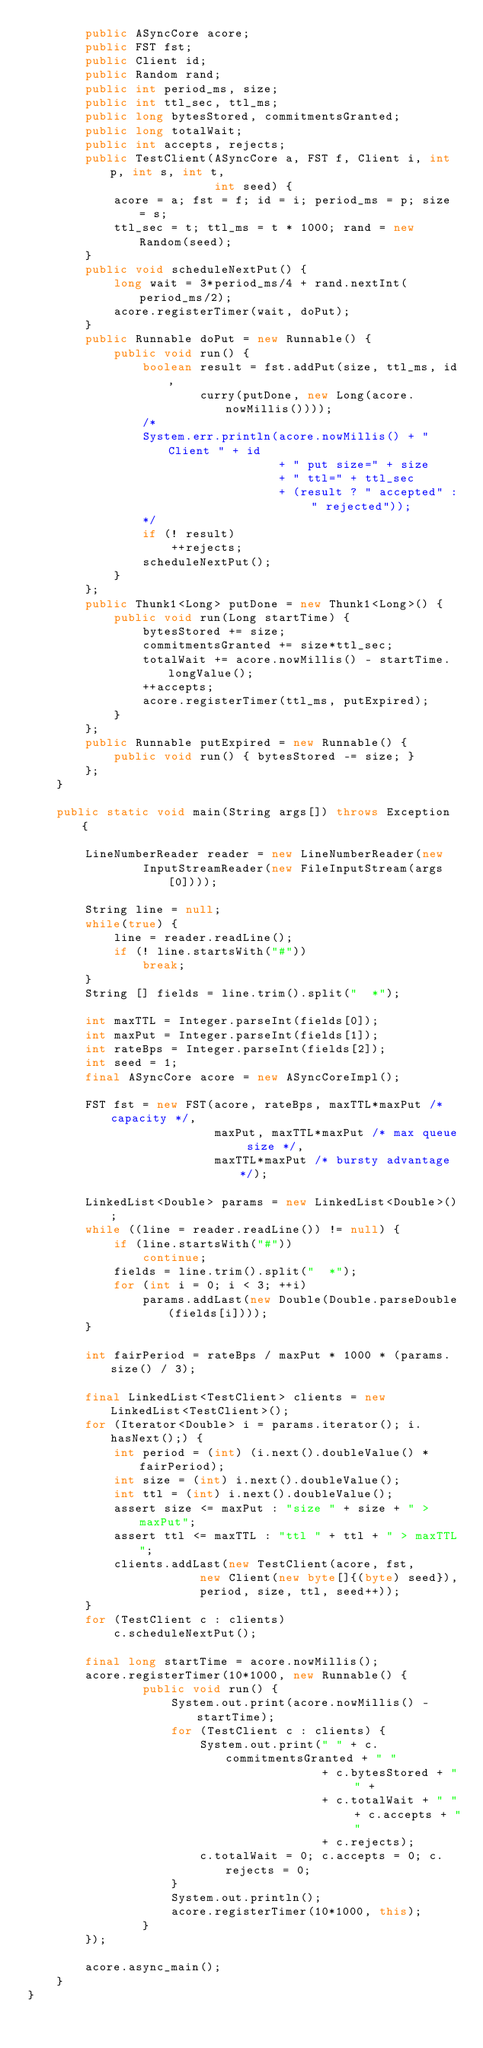<code> <loc_0><loc_0><loc_500><loc_500><_Java_>        public ASyncCore acore;
        public FST fst;
        public Client id;
        public Random rand;
        public int period_ms, size;
        public int ttl_sec, ttl_ms;
        public long bytesStored, commitmentsGranted;
        public long totalWait;
        public int accepts, rejects;
        public TestClient(ASyncCore a, FST f, Client i, int p, int s, int t,
                          int seed) {
            acore = a; fst = f; id = i; period_ms = p; size = s; 
            ttl_sec = t; ttl_ms = t * 1000; rand = new Random(seed);
        }
        public void scheduleNextPut() {
            long wait = 3*period_ms/4 + rand.nextInt(period_ms/2);
            acore.registerTimer(wait, doPut);
        }
        public Runnable doPut = new Runnable() {
            public void run() {
                boolean result = fst.addPut(size, ttl_ms, id, 
                        curry(putDone, new Long(acore.nowMillis())));
                /*
                System.err.println(acore.nowMillis() + " Client " + id 
                                   + " put size=" + size 
                                   + " ttl=" + ttl_sec 
                                   + (result ? " accepted" : " rejected"));
                */
                if (! result)
                    ++rejects;
                scheduleNextPut();
            }
        };
        public Thunk1<Long> putDone = new Thunk1<Long>() {
            public void run(Long startTime) {
                bytesStored += size;
                commitmentsGranted += size*ttl_sec;
                totalWait += acore.nowMillis() - startTime.longValue();
                ++accepts;
                acore.registerTimer(ttl_ms, putExpired);
            }
        };
        public Runnable putExpired = new Runnable() {
            public void run() { bytesStored -= size; }
        };
    }

    public static void main(String args[]) throws Exception {

        LineNumberReader reader = new LineNumberReader(new
                InputStreamReader(new FileInputStream(args[0])));

        String line = null;
        while(true) {
            line = reader.readLine();
            if (! line.startsWith("#"))
                break;
        }
        String [] fields = line.trim().split("  *");

        int maxTTL = Integer.parseInt(fields[0]);
        int maxPut = Integer.parseInt(fields[1]);
        int rateBps = Integer.parseInt(fields[2]);
        int seed = 1;
        final ASyncCore acore = new ASyncCoreImpl();

        FST fst = new FST(acore, rateBps, maxTTL*maxPut /* capacity */, 
                          maxPut, maxTTL*maxPut /* max queue size */, 
                          maxTTL*maxPut /* bursty advantage */);

        LinkedList<Double> params = new LinkedList<Double>();
        while ((line = reader.readLine()) != null) {
            if (line.startsWith("#"))
                continue;
            fields = line.trim().split("  *");
            for (int i = 0; i < 3; ++i)
                params.addLast(new Double(Double.parseDouble(fields[i])));
        }

        int fairPeriod = rateBps / maxPut * 1000 * (params.size() / 3);

        final LinkedList<TestClient> clients = new LinkedList<TestClient>();
        for (Iterator<Double> i = params.iterator(); i.hasNext();) {
            int period = (int) (i.next().doubleValue() * fairPeriod);
            int size = (int) i.next().doubleValue();
            int ttl = (int) i.next().doubleValue();
            assert size <= maxPut : "size " + size + " > maxPut";
            assert ttl <= maxTTL : "ttl " + ttl + " > maxTTL";
            clients.addLast(new TestClient(acore, fst, 
                        new Client(new byte[]{(byte) seed}), 
                        period, size, ttl, seed++));
        }
        for (TestClient c : clients)
            c.scheduleNextPut();

        final long startTime = acore.nowMillis();
        acore.registerTimer(10*1000, new Runnable() {
                public void run() {
                    System.out.print(acore.nowMillis() - startTime);
                    for (TestClient c : clients) {
                        System.out.print(" " + c.commitmentsGranted + " " 
                                         + c.bytesStored + " " +
                                         + c.totalWait + " " + c.accepts + " "
                                         + c.rejects);
                        c.totalWait = 0; c.accepts = 0; c.rejects = 0;
                    }
                    System.out.println();
                    acore.registerTimer(10*1000, this);
                }
        });

        acore.async_main();
    }
}

</code> 